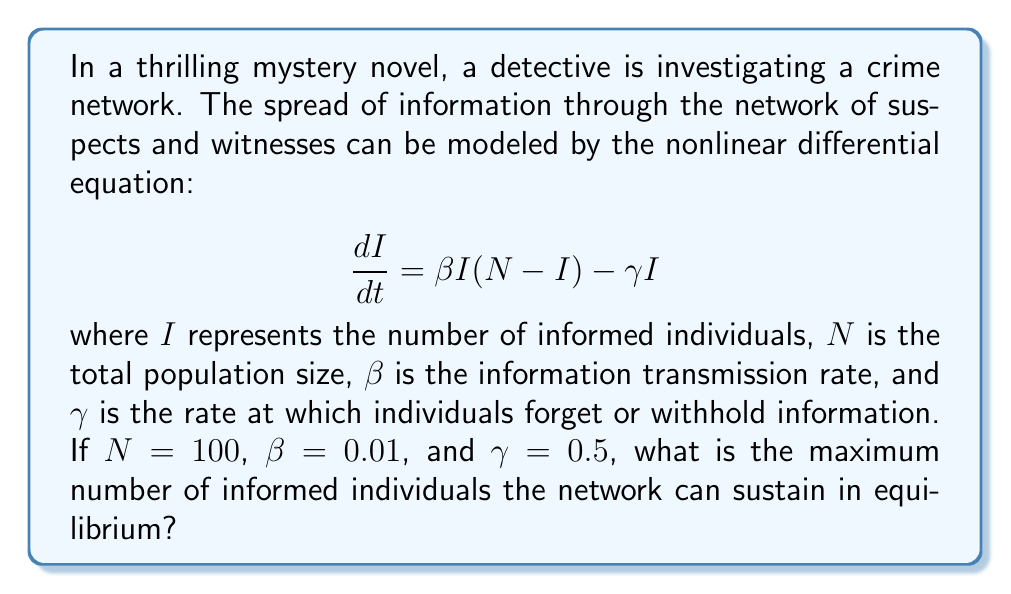Help me with this question. To solve this problem, we need to follow these steps:

1) In equilibrium, the rate of change of informed individuals is zero. So, we set $\frac{dI}{dt} = 0$:

   $$0 = \beta I(N-I) - \gamma I$$

2) Factor out $I$:

   $$0 = I(\beta(N-I) - \gamma)$$

3) This equation is satisfied when either $I = 0$ or when $\beta(N-I) - \gamma = 0$. The non-zero solution is what we're interested in, so:

   $$\beta(N-I) - \gamma = 0$$

4) Solve for $I$:

   $$\beta N - \beta I = \gamma$$
   $$\beta N - \gamma = \beta I$$
   $$I = \frac{\beta N - \gamma}{\beta}$$

5) Substitute the given values: $N = 100$, $\beta = 0.01$, and $\gamma = 0.5$

   $$I = \frac{0.01 * 100 - 0.5}{0.01} = \frac{1 - 0.5}{0.01} = \frac{0.5}{0.01} = 50$$

Therefore, the maximum number of informed individuals the network can sustain in equilibrium is 50.
Answer: 50 individuals 